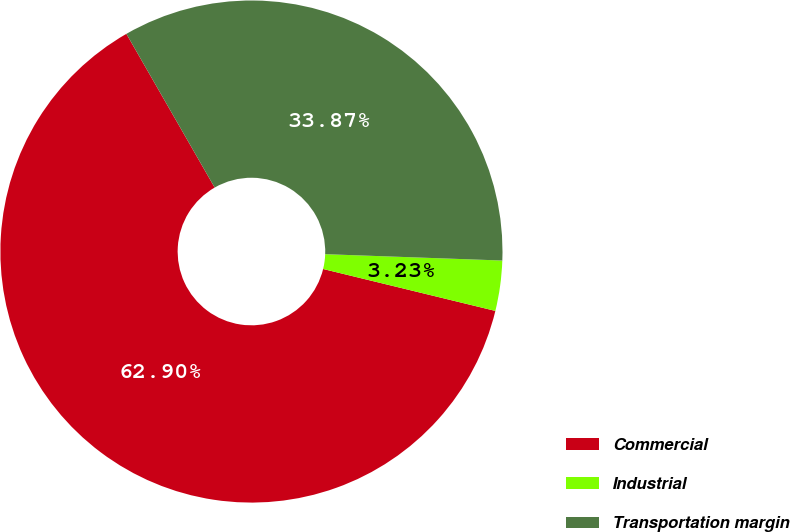Convert chart. <chart><loc_0><loc_0><loc_500><loc_500><pie_chart><fcel>Commercial<fcel>Industrial<fcel>Transportation margin<nl><fcel>62.9%<fcel>3.23%<fcel>33.87%<nl></chart> 